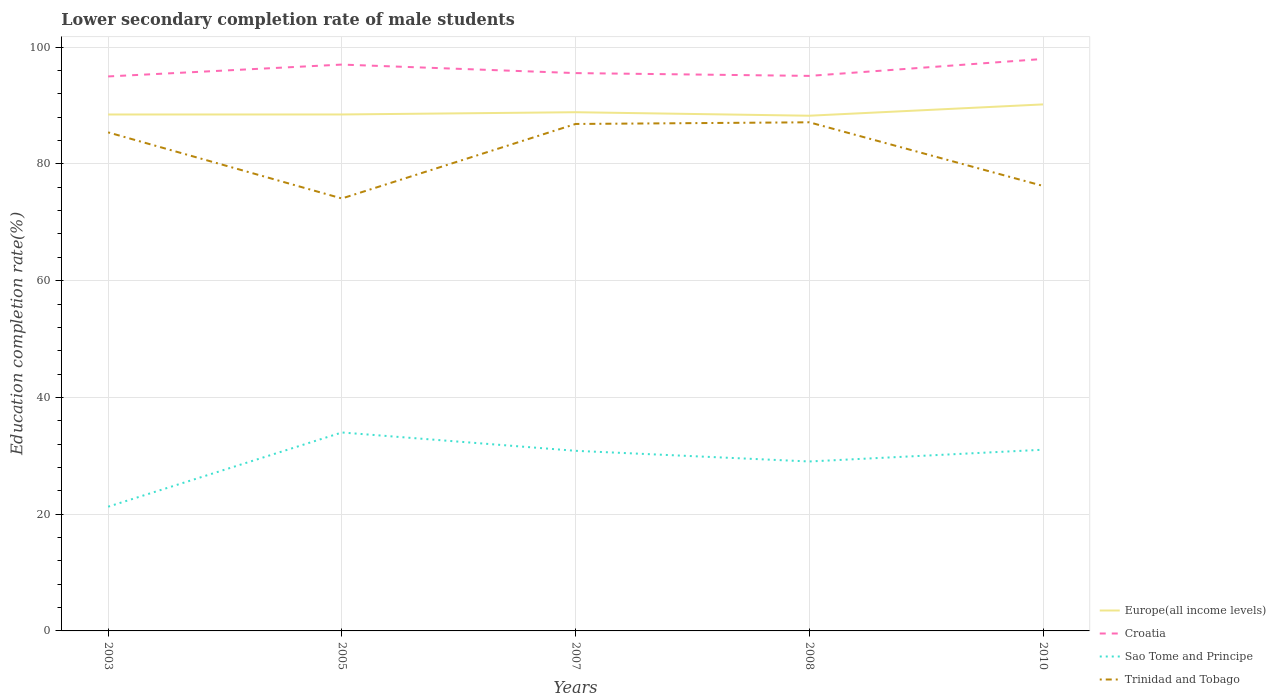Across all years, what is the maximum lower secondary completion rate of male students in Croatia?
Provide a short and direct response. 94.98. In which year was the lower secondary completion rate of male students in Croatia maximum?
Your answer should be very brief. 2003. What is the total lower secondary completion rate of male students in Croatia in the graph?
Give a very brief answer. 1.94. What is the difference between the highest and the second highest lower secondary completion rate of male students in Europe(all income levels)?
Offer a very short reply. 1.94. What is the difference between the highest and the lowest lower secondary completion rate of male students in Trinidad and Tobago?
Your response must be concise. 3. Is the lower secondary completion rate of male students in Sao Tome and Principe strictly greater than the lower secondary completion rate of male students in Croatia over the years?
Your answer should be very brief. Yes. How many years are there in the graph?
Make the answer very short. 5. What is the difference between two consecutive major ticks on the Y-axis?
Offer a terse response. 20. Are the values on the major ticks of Y-axis written in scientific E-notation?
Offer a very short reply. No. Where does the legend appear in the graph?
Provide a succinct answer. Bottom right. How many legend labels are there?
Your answer should be compact. 4. What is the title of the graph?
Offer a terse response. Lower secondary completion rate of male students. What is the label or title of the Y-axis?
Give a very brief answer. Education completion rate(%). What is the Education completion rate(%) in Europe(all income levels) in 2003?
Your answer should be very brief. 88.46. What is the Education completion rate(%) in Croatia in 2003?
Keep it short and to the point. 94.98. What is the Education completion rate(%) of Sao Tome and Principe in 2003?
Make the answer very short. 21.28. What is the Education completion rate(%) in Trinidad and Tobago in 2003?
Your answer should be compact. 85.4. What is the Education completion rate(%) in Europe(all income levels) in 2005?
Make the answer very short. 88.47. What is the Education completion rate(%) in Croatia in 2005?
Your answer should be very brief. 97.02. What is the Education completion rate(%) of Sao Tome and Principe in 2005?
Your response must be concise. 33.99. What is the Education completion rate(%) in Trinidad and Tobago in 2005?
Give a very brief answer. 74.08. What is the Education completion rate(%) in Europe(all income levels) in 2007?
Make the answer very short. 88.85. What is the Education completion rate(%) in Croatia in 2007?
Give a very brief answer. 95.56. What is the Education completion rate(%) of Sao Tome and Principe in 2007?
Your answer should be compact. 30.85. What is the Education completion rate(%) in Trinidad and Tobago in 2007?
Keep it short and to the point. 86.84. What is the Education completion rate(%) of Europe(all income levels) in 2008?
Make the answer very short. 88.25. What is the Education completion rate(%) in Croatia in 2008?
Your answer should be compact. 95.08. What is the Education completion rate(%) of Sao Tome and Principe in 2008?
Keep it short and to the point. 29.03. What is the Education completion rate(%) of Trinidad and Tobago in 2008?
Offer a terse response. 87.13. What is the Education completion rate(%) of Europe(all income levels) in 2010?
Your answer should be compact. 90.19. What is the Education completion rate(%) of Croatia in 2010?
Your response must be concise. 97.98. What is the Education completion rate(%) in Sao Tome and Principe in 2010?
Your answer should be compact. 31.04. What is the Education completion rate(%) in Trinidad and Tobago in 2010?
Make the answer very short. 76.23. Across all years, what is the maximum Education completion rate(%) in Europe(all income levels)?
Provide a short and direct response. 90.19. Across all years, what is the maximum Education completion rate(%) in Croatia?
Your answer should be compact. 97.98. Across all years, what is the maximum Education completion rate(%) of Sao Tome and Principe?
Keep it short and to the point. 33.99. Across all years, what is the maximum Education completion rate(%) in Trinidad and Tobago?
Your answer should be compact. 87.13. Across all years, what is the minimum Education completion rate(%) of Europe(all income levels)?
Provide a short and direct response. 88.25. Across all years, what is the minimum Education completion rate(%) in Croatia?
Your response must be concise. 94.98. Across all years, what is the minimum Education completion rate(%) in Sao Tome and Principe?
Offer a terse response. 21.28. Across all years, what is the minimum Education completion rate(%) of Trinidad and Tobago?
Provide a short and direct response. 74.08. What is the total Education completion rate(%) of Europe(all income levels) in the graph?
Make the answer very short. 444.23. What is the total Education completion rate(%) in Croatia in the graph?
Provide a short and direct response. 480.61. What is the total Education completion rate(%) in Sao Tome and Principe in the graph?
Ensure brevity in your answer.  146.19. What is the total Education completion rate(%) in Trinidad and Tobago in the graph?
Offer a terse response. 409.68. What is the difference between the Education completion rate(%) in Europe(all income levels) in 2003 and that in 2005?
Give a very brief answer. -0.01. What is the difference between the Education completion rate(%) in Croatia in 2003 and that in 2005?
Give a very brief answer. -2.03. What is the difference between the Education completion rate(%) in Sao Tome and Principe in 2003 and that in 2005?
Keep it short and to the point. -12.72. What is the difference between the Education completion rate(%) in Trinidad and Tobago in 2003 and that in 2005?
Offer a very short reply. 11.32. What is the difference between the Education completion rate(%) of Europe(all income levels) in 2003 and that in 2007?
Keep it short and to the point. -0.39. What is the difference between the Education completion rate(%) of Croatia in 2003 and that in 2007?
Offer a very short reply. -0.57. What is the difference between the Education completion rate(%) in Sao Tome and Principe in 2003 and that in 2007?
Make the answer very short. -9.57. What is the difference between the Education completion rate(%) of Trinidad and Tobago in 2003 and that in 2007?
Ensure brevity in your answer.  -1.44. What is the difference between the Education completion rate(%) of Europe(all income levels) in 2003 and that in 2008?
Make the answer very short. 0.21. What is the difference between the Education completion rate(%) of Croatia in 2003 and that in 2008?
Make the answer very short. -0.09. What is the difference between the Education completion rate(%) of Sao Tome and Principe in 2003 and that in 2008?
Provide a short and direct response. -7.75. What is the difference between the Education completion rate(%) of Trinidad and Tobago in 2003 and that in 2008?
Your response must be concise. -1.73. What is the difference between the Education completion rate(%) of Europe(all income levels) in 2003 and that in 2010?
Provide a short and direct response. -1.73. What is the difference between the Education completion rate(%) of Croatia in 2003 and that in 2010?
Your answer should be compact. -2.99. What is the difference between the Education completion rate(%) in Sao Tome and Principe in 2003 and that in 2010?
Keep it short and to the point. -9.76. What is the difference between the Education completion rate(%) in Trinidad and Tobago in 2003 and that in 2010?
Offer a very short reply. 9.17. What is the difference between the Education completion rate(%) of Europe(all income levels) in 2005 and that in 2007?
Provide a short and direct response. -0.39. What is the difference between the Education completion rate(%) in Croatia in 2005 and that in 2007?
Keep it short and to the point. 1.46. What is the difference between the Education completion rate(%) of Sao Tome and Principe in 2005 and that in 2007?
Offer a terse response. 3.14. What is the difference between the Education completion rate(%) of Trinidad and Tobago in 2005 and that in 2007?
Provide a succinct answer. -12.76. What is the difference between the Education completion rate(%) of Europe(all income levels) in 2005 and that in 2008?
Keep it short and to the point. 0.21. What is the difference between the Education completion rate(%) in Croatia in 2005 and that in 2008?
Your answer should be compact. 1.94. What is the difference between the Education completion rate(%) of Sao Tome and Principe in 2005 and that in 2008?
Keep it short and to the point. 4.97. What is the difference between the Education completion rate(%) of Trinidad and Tobago in 2005 and that in 2008?
Offer a terse response. -13.05. What is the difference between the Education completion rate(%) in Europe(all income levels) in 2005 and that in 2010?
Make the answer very short. -1.72. What is the difference between the Education completion rate(%) in Croatia in 2005 and that in 2010?
Keep it short and to the point. -0.96. What is the difference between the Education completion rate(%) of Sao Tome and Principe in 2005 and that in 2010?
Ensure brevity in your answer.  2.96. What is the difference between the Education completion rate(%) of Trinidad and Tobago in 2005 and that in 2010?
Provide a short and direct response. -2.15. What is the difference between the Education completion rate(%) of Europe(all income levels) in 2007 and that in 2008?
Provide a short and direct response. 0.6. What is the difference between the Education completion rate(%) of Croatia in 2007 and that in 2008?
Offer a very short reply. 0.48. What is the difference between the Education completion rate(%) in Sao Tome and Principe in 2007 and that in 2008?
Ensure brevity in your answer.  1.83. What is the difference between the Education completion rate(%) in Trinidad and Tobago in 2007 and that in 2008?
Offer a terse response. -0.29. What is the difference between the Education completion rate(%) in Europe(all income levels) in 2007 and that in 2010?
Your answer should be compact. -1.34. What is the difference between the Education completion rate(%) of Croatia in 2007 and that in 2010?
Offer a terse response. -2.42. What is the difference between the Education completion rate(%) in Sao Tome and Principe in 2007 and that in 2010?
Offer a terse response. -0.19. What is the difference between the Education completion rate(%) of Trinidad and Tobago in 2007 and that in 2010?
Ensure brevity in your answer.  10.61. What is the difference between the Education completion rate(%) in Europe(all income levels) in 2008 and that in 2010?
Your answer should be compact. -1.94. What is the difference between the Education completion rate(%) in Croatia in 2008 and that in 2010?
Offer a terse response. -2.9. What is the difference between the Education completion rate(%) in Sao Tome and Principe in 2008 and that in 2010?
Provide a short and direct response. -2.01. What is the difference between the Education completion rate(%) of Trinidad and Tobago in 2008 and that in 2010?
Make the answer very short. 10.9. What is the difference between the Education completion rate(%) in Europe(all income levels) in 2003 and the Education completion rate(%) in Croatia in 2005?
Offer a terse response. -8.55. What is the difference between the Education completion rate(%) of Europe(all income levels) in 2003 and the Education completion rate(%) of Sao Tome and Principe in 2005?
Ensure brevity in your answer.  54.47. What is the difference between the Education completion rate(%) of Europe(all income levels) in 2003 and the Education completion rate(%) of Trinidad and Tobago in 2005?
Give a very brief answer. 14.39. What is the difference between the Education completion rate(%) of Croatia in 2003 and the Education completion rate(%) of Sao Tome and Principe in 2005?
Ensure brevity in your answer.  60.99. What is the difference between the Education completion rate(%) in Croatia in 2003 and the Education completion rate(%) in Trinidad and Tobago in 2005?
Your response must be concise. 20.91. What is the difference between the Education completion rate(%) of Sao Tome and Principe in 2003 and the Education completion rate(%) of Trinidad and Tobago in 2005?
Make the answer very short. -52.8. What is the difference between the Education completion rate(%) of Europe(all income levels) in 2003 and the Education completion rate(%) of Croatia in 2007?
Make the answer very short. -7.09. What is the difference between the Education completion rate(%) in Europe(all income levels) in 2003 and the Education completion rate(%) in Sao Tome and Principe in 2007?
Give a very brief answer. 57.61. What is the difference between the Education completion rate(%) in Europe(all income levels) in 2003 and the Education completion rate(%) in Trinidad and Tobago in 2007?
Offer a very short reply. 1.62. What is the difference between the Education completion rate(%) in Croatia in 2003 and the Education completion rate(%) in Sao Tome and Principe in 2007?
Make the answer very short. 64.13. What is the difference between the Education completion rate(%) of Croatia in 2003 and the Education completion rate(%) of Trinidad and Tobago in 2007?
Offer a very short reply. 8.14. What is the difference between the Education completion rate(%) of Sao Tome and Principe in 2003 and the Education completion rate(%) of Trinidad and Tobago in 2007?
Keep it short and to the point. -65.56. What is the difference between the Education completion rate(%) of Europe(all income levels) in 2003 and the Education completion rate(%) of Croatia in 2008?
Give a very brief answer. -6.61. What is the difference between the Education completion rate(%) in Europe(all income levels) in 2003 and the Education completion rate(%) in Sao Tome and Principe in 2008?
Give a very brief answer. 59.44. What is the difference between the Education completion rate(%) in Europe(all income levels) in 2003 and the Education completion rate(%) in Trinidad and Tobago in 2008?
Offer a very short reply. 1.34. What is the difference between the Education completion rate(%) of Croatia in 2003 and the Education completion rate(%) of Sao Tome and Principe in 2008?
Offer a terse response. 65.96. What is the difference between the Education completion rate(%) of Croatia in 2003 and the Education completion rate(%) of Trinidad and Tobago in 2008?
Keep it short and to the point. 7.86. What is the difference between the Education completion rate(%) of Sao Tome and Principe in 2003 and the Education completion rate(%) of Trinidad and Tobago in 2008?
Offer a terse response. -65.85. What is the difference between the Education completion rate(%) of Europe(all income levels) in 2003 and the Education completion rate(%) of Croatia in 2010?
Keep it short and to the point. -9.51. What is the difference between the Education completion rate(%) in Europe(all income levels) in 2003 and the Education completion rate(%) in Sao Tome and Principe in 2010?
Your answer should be compact. 57.42. What is the difference between the Education completion rate(%) of Europe(all income levels) in 2003 and the Education completion rate(%) of Trinidad and Tobago in 2010?
Provide a succinct answer. 12.23. What is the difference between the Education completion rate(%) of Croatia in 2003 and the Education completion rate(%) of Sao Tome and Principe in 2010?
Offer a terse response. 63.94. What is the difference between the Education completion rate(%) in Croatia in 2003 and the Education completion rate(%) in Trinidad and Tobago in 2010?
Provide a short and direct response. 18.75. What is the difference between the Education completion rate(%) in Sao Tome and Principe in 2003 and the Education completion rate(%) in Trinidad and Tobago in 2010?
Make the answer very short. -54.95. What is the difference between the Education completion rate(%) in Europe(all income levels) in 2005 and the Education completion rate(%) in Croatia in 2007?
Your response must be concise. -7.09. What is the difference between the Education completion rate(%) in Europe(all income levels) in 2005 and the Education completion rate(%) in Sao Tome and Principe in 2007?
Your response must be concise. 57.62. What is the difference between the Education completion rate(%) of Europe(all income levels) in 2005 and the Education completion rate(%) of Trinidad and Tobago in 2007?
Ensure brevity in your answer.  1.63. What is the difference between the Education completion rate(%) of Croatia in 2005 and the Education completion rate(%) of Sao Tome and Principe in 2007?
Offer a terse response. 66.16. What is the difference between the Education completion rate(%) of Croatia in 2005 and the Education completion rate(%) of Trinidad and Tobago in 2007?
Your response must be concise. 10.17. What is the difference between the Education completion rate(%) in Sao Tome and Principe in 2005 and the Education completion rate(%) in Trinidad and Tobago in 2007?
Ensure brevity in your answer.  -52.85. What is the difference between the Education completion rate(%) of Europe(all income levels) in 2005 and the Education completion rate(%) of Croatia in 2008?
Offer a terse response. -6.61. What is the difference between the Education completion rate(%) of Europe(all income levels) in 2005 and the Education completion rate(%) of Sao Tome and Principe in 2008?
Ensure brevity in your answer.  59.44. What is the difference between the Education completion rate(%) in Europe(all income levels) in 2005 and the Education completion rate(%) in Trinidad and Tobago in 2008?
Give a very brief answer. 1.34. What is the difference between the Education completion rate(%) of Croatia in 2005 and the Education completion rate(%) of Sao Tome and Principe in 2008?
Provide a succinct answer. 67.99. What is the difference between the Education completion rate(%) of Croatia in 2005 and the Education completion rate(%) of Trinidad and Tobago in 2008?
Keep it short and to the point. 9.89. What is the difference between the Education completion rate(%) of Sao Tome and Principe in 2005 and the Education completion rate(%) of Trinidad and Tobago in 2008?
Your answer should be compact. -53.13. What is the difference between the Education completion rate(%) of Europe(all income levels) in 2005 and the Education completion rate(%) of Croatia in 2010?
Offer a terse response. -9.51. What is the difference between the Education completion rate(%) in Europe(all income levels) in 2005 and the Education completion rate(%) in Sao Tome and Principe in 2010?
Give a very brief answer. 57.43. What is the difference between the Education completion rate(%) of Europe(all income levels) in 2005 and the Education completion rate(%) of Trinidad and Tobago in 2010?
Make the answer very short. 12.24. What is the difference between the Education completion rate(%) of Croatia in 2005 and the Education completion rate(%) of Sao Tome and Principe in 2010?
Give a very brief answer. 65.98. What is the difference between the Education completion rate(%) of Croatia in 2005 and the Education completion rate(%) of Trinidad and Tobago in 2010?
Make the answer very short. 20.79. What is the difference between the Education completion rate(%) of Sao Tome and Principe in 2005 and the Education completion rate(%) of Trinidad and Tobago in 2010?
Provide a succinct answer. -42.23. What is the difference between the Education completion rate(%) in Europe(all income levels) in 2007 and the Education completion rate(%) in Croatia in 2008?
Offer a terse response. -6.22. What is the difference between the Education completion rate(%) in Europe(all income levels) in 2007 and the Education completion rate(%) in Sao Tome and Principe in 2008?
Your response must be concise. 59.83. What is the difference between the Education completion rate(%) in Europe(all income levels) in 2007 and the Education completion rate(%) in Trinidad and Tobago in 2008?
Make the answer very short. 1.73. What is the difference between the Education completion rate(%) in Croatia in 2007 and the Education completion rate(%) in Sao Tome and Principe in 2008?
Your answer should be compact. 66.53. What is the difference between the Education completion rate(%) in Croatia in 2007 and the Education completion rate(%) in Trinidad and Tobago in 2008?
Ensure brevity in your answer.  8.43. What is the difference between the Education completion rate(%) of Sao Tome and Principe in 2007 and the Education completion rate(%) of Trinidad and Tobago in 2008?
Offer a very short reply. -56.27. What is the difference between the Education completion rate(%) in Europe(all income levels) in 2007 and the Education completion rate(%) in Croatia in 2010?
Give a very brief answer. -9.12. What is the difference between the Education completion rate(%) of Europe(all income levels) in 2007 and the Education completion rate(%) of Sao Tome and Principe in 2010?
Offer a very short reply. 57.81. What is the difference between the Education completion rate(%) of Europe(all income levels) in 2007 and the Education completion rate(%) of Trinidad and Tobago in 2010?
Keep it short and to the point. 12.62. What is the difference between the Education completion rate(%) of Croatia in 2007 and the Education completion rate(%) of Sao Tome and Principe in 2010?
Your answer should be very brief. 64.52. What is the difference between the Education completion rate(%) in Croatia in 2007 and the Education completion rate(%) in Trinidad and Tobago in 2010?
Ensure brevity in your answer.  19.33. What is the difference between the Education completion rate(%) of Sao Tome and Principe in 2007 and the Education completion rate(%) of Trinidad and Tobago in 2010?
Keep it short and to the point. -45.38. What is the difference between the Education completion rate(%) of Europe(all income levels) in 2008 and the Education completion rate(%) of Croatia in 2010?
Your answer should be compact. -9.72. What is the difference between the Education completion rate(%) of Europe(all income levels) in 2008 and the Education completion rate(%) of Sao Tome and Principe in 2010?
Your response must be concise. 57.21. What is the difference between the Education completion rate(%) of Europe(all income levels) in 2008 and the Education completion rate(%) of Trinidad and Tobago in 2010?
Offer a terse response. 12.02. What is the difference between the Education completion rate(%) of Croatia in 2008 and the Education completion rate(%) of Sao Tome and Principe in 2010?
Offer a very short reply. 64.04. What is the difference between the Education completion rate(%) in Croatia in 2008 and the Education completion rate(%) in Trinidad and Tobago in 2010?
Give a very brief answer. 18.85. What is the difference between the Education completion rate(%) of Sao Tome and Principe in 2008 and the Education completion rate(%) of Trinidad and Tobago in 2010?
Offer a very short reply. -47.2. What is the average Education completion rate(%) of Europe(all income levels) per year?
Keep it short and to the point. 88.85. What is the average Education completion rate(%) of Croatia per year?
Make the answer very short. 96.12. What is the average Education completion rate(%) in Sao Tome and Principe per year?
Offer a terse response. 29.24. What is the average Education completion rate(%) in Trinidad and Tobago per year?
Ensure brevity in your answer.  81.94. In the year 2003, what is the difference between the Education completion rate(%) in Europe(all income levels) and Education completion rate(%) in Croatia?
Give a very brief answer. -6.52. In the year 2003, what is the difference between the Education completion rate(%) in Europe(all income levels) and Education completion rate(%) in Sao Tome and Principe?
Give a very brief answer. 67.18. In the year 2003, what is the difference between the Education completion rate(%) of Europe(all income levels) and Education completion rate(%) of Trinidad and Tobago?
Keep it short and to the point. 3.06. In the year 2003, what is the difference between the Education completion rate(%) in Croatia and Education completion rate(%) in Sao Tome and Principe?
Provide a succinct answer. 73.7. In the year 2003, what is the difference between the Education completion rate(%) of Croatia and Education completion rate(%) of Trinidad and Tobago?
Offer a terse response. 9.58. In the year 2003, what is the difference between the Education completion rate(%) in Sao Tome and Principe and Education completion rate(%) in Trinidad and Tobago?
Provide a succinct answer. -64.12. In the year 2005, what is the difference between the Education completion rate(%) in Europe(all income levels) and Education completion rate(%) in Croatia?
Your response must be concise. -8.55. In the year 2005, what is the difference between the Education completion rate(%) of Europe(all income levels) and Education completion rate(%) of Sao Tome and Principe?
Ensure brevity in your answer.  54.47. In the year 2005, what is the difference between the Education completion rate(%) of Europe(all income levels) and Education completion rate(%) of Trinidad and Tobago?
Make the answer very short. 14.39. In the year 2005, what is the difference between the Education completion rate(%) of Croatia and Education completion rate(%) of Sao Tome and Principe?
Give a very brief answer. 63.02. In the year 2005, what is the difference between the Education completion rate(%) in Croatia and Education completion rate(%) in Trinidad and Tobago?
Your answer should be compact. 22.94. In the year 2005, what is the difference between the Education completion rate(%) of Sao Tome and Principe and Education completion rate(%) of Trinidad and Tobago?
Give a very brief answer. -40.08. In the year 2007, what is the difference between the Education completion rate(%) of Europe(all income levels) and Education completion rate(%) of Croatia?
Offer a very short reply. -6.7. In the year 2007, what is the difference between the Education completion rate(%) of Europe(all income levels) and Education completion rate(%) of Sao Tome and Principe?
Your response must be concise. 58. In the year 2007, what is the difference between the Education completion rate(%) in Europe(all income levels) and Education completion rate(%) in Trinidad and Tobago?
Offer a very short reply. 2.01. In the year 2007, what is the difference between the Education completion rate(%) of Croatia and Education completion rate(%) of Sao Tome and Principe?
Offer a terse response. 64.7. In the year 2007, what is the difference between the Education completion rate(%) in Croatia and Education completion rate(%) in Trinidad and Tobago?
Give a very brief answer. 8.72. In the year 2007, what is the difference between the Education completion rate(%) of Sao Tome and Principe and Education completion rate(%) of Trinidad and Tobago?
Provide a short and direct response. -55.99. In the year 2008, what is the difference between the Education completion rate(%) in Europe(all income levels) and Education completion rate(%) in Croatia?
Provide a succinct answer. -6.82. In the year 2008, what is the difference between the Education completion rate(%) of Europe(all income levels) and Education completion rate(%) of Sao Tome and Principe?
Offer a terse response. 59.23. In the year 2008, what is the difference between the Education completion rate(%) in Europe(all income levels) and Education completion rate(%) in Trinidad and Tobago?
Ensure brevity in your answer.  1.13. In the year 2008, what is the difference between the Education completion rate(%) in Croatia and Education completion rate(%) in Sao Tome and Principe?
Your answer should be compact. 66.05. In the year 2008, what is the difference between the Education completion rate(%) of Croatia and Education completion rate(%) of Trinidad and Tobago?
Ensure brevity in your answer.  7.95. In the year 2008, what is the difference between the Education completion rate(%) in Sao Tome and Principe and Education completion rate(%) in Trinidad and Tobago?
Make the answer very short. -58.1. In the year 2010, what is the difference between the Education completion rate(%) of Europe(all income levels) and Education completion rate(%) of Croatia?
Offer a terse response. -7.79. In the year 2010, what is the difference between the Education completion rate(%) of Europe(all income levels) and Education completion rate(%) of Sao Tome and Principe?
Offer a terse response. 59.15. In the year 2010, what is the difference between the Education completion rate(%) of Europe(all income levels) and Education completion rate(%) of Trinidad and Tobago?
Your response must be concise. 13.96. In the year 2010, what is the difference between the Education completion rate(%) in Croatia and Education completion rate(%) in Sao Tome and Principe?
Offer a very short reply. 66.94. In the year 2010, what is the difference between the Education completion rate(%) in Croatia and Education completion rate(%) in Trinidad and Tobago?
Make the answer very short. 21.75. In the year 2010, what is the difference between the Education completion rate(%) of Sao Tome and Principe and Education completion rate(%) of Trinidad and Tobago?
Provide a succinct answer. -45.19. What is the ratio of the Education completion rate(%) in Europe(all income levels) in 2003 to that in 2005?
Make the answer very short. 1. What is the ratio of the Education completion rate(%) of Croatia in 2003 to that in 2005?
Provide a succinct answer. 0.98. What is the ratio of the Education completion rate(%) of Sao Tome and Principe in 2003 to that in 2005?
Keep it short and to the point. 0.63. What is the ratio of the Education completion rate(%) of Trinidad and Tobago in 2003 to that in 2005?
Your answer should be compact. 1.15. What is the ratio of the Education completion rate(%) of Croatia in 2003 to that in 2007?
Your answer should be very brief. 0.99. What is the ratio of the Education completion rate(%) in Sao Tome and Principe in 2003 to that in 2007?
Offer a very short reply. 0.69. What is the ratio of the Education completion rate(%) in Trinidad and Tobago in 2003 to that in 2007?
Keep it short and to the point. 0.98. What is the ratio of the Education completion rate(%) of Croatia in 2003 to that in 2008?
Your answer should be compact. 1. What is the ratio of the Education completion rate(%) in Sao Tome and Principe in 2003 to that in 2008?
Keep it short and to the point. 0.73. What is the ratio of the Education completion rate(%) of Trinidad and Tobago in 2003 to that in 2008?
Your response must be concise. 0.98. What is the ratio of the Education completion rate(%) of Europe(all income levels) in 2003 to that in 2010?
Ensure brevity in your answer.  0.98. What is the ratio of the Education completion rate(%) in Croatia in 2003 to that in 2010?
Offer a very short reply. 0.97. What is the ratio of the Education completion rate(%) of Sao Tome and Principe in 2003 to that in 2010?
Provide a succinct answer. 0.69. What is the ratio of the Education completion rate(%) of Trinidad and Tobago in 2003 to that in 2010?
Your answer should be very brief. 1.12. What is the ratio of the Education completion rate(%) of Europe(all income levels) in 2005 to that in 2007?
Your answer should be very brief. 1. What is the ratio of the Education completion rate(%) of Croatia in 2005 to that in 2007?
Your answer should be very brief. 1.02. What is the ratio of the Education completion rate(%) in Sao Tome and Principe in 2005 to that in 2007?
Give a very brief answer. 1.1. What is the ratio of the Education completion rate(%) of Trinidad and Tobago in 2005 to that in 2007?
Keep it short and to the point. 0.85. What is the ratio of the Education completion rate(%) of Europe(all income levels) in 2005 to that in 2008?
Ensure brevity in your answer.  1. What is the ratio of the Education completion rate(%) in Croatia in 2005 to that in 2008?
Offer a very short reply. 1.02. What is the ratio of the Education completion rate(%) of Sao Tome and Principe in 2005 to that in 2008?
Make the answer very short. 1.17. What is the ratio of the Education completion rate(%) of Trinidad and Tobago in 2005 to that in 2008?
Ensure brevity in your answer.  0.85. What is the ratio of the Education completion rate(%) in Europe(all income levels) in 2005 to that in 2010?
Give a very brief answer. 0.98. What is the ratio of the Education completion rate(%) in Croatia in 2005 to that in 2010?
Your response must be concise. 0.99. What is the ratio of the Education completion rate(%) of Sao Tome and Principe in 2005 to that in 2010?
Provide a succinct answer. 1.1. What is the ratio of the Education completion rate(%) in Trinidad and Tobago in 2005 to that in 2010?
Your answer should be very brief. 0.97. What is the ratio of the Education completion rate(%) of Europe(all income levels) in 2007 to that in 2008?
Keep it short and to the point. 1.01. What is the ratio of the Education completion rate(%) in Croatia in 2007 to that in 2008?
Your answer should be very brief. 1.01. What is the ratio of the Education completion rate(%) in Sao Tome and Principe in 2007 to that in 2008?
Your answer should be compact. 1.06. What is the ratio of the Education completion rate(%) in Europe(all income levels) in 2007 to that in 2010?
Make the answer very short. 0.99. What is the ratio of the Education completion rate(%) of Croatia in 2007 to that in 2010?
Keep it short and to the point. 0.98. What is the ratio of the Education completion rate(%) of Trinidad and Tobago in 2007 to that in 2010?
Offer a terse response. 1.14. What is the ratio of the Education completion rate(%) of Europe(all income levels) in 2008 to that in 2010?
Make the answer very short. 0.98. What is the ratio of the Education completion rate(%) of Croatia in 2008 to that in 2010?
Your answer should be compact. 0.97. What is the ratio of the Education completion rate(%) of Sao Tome and Principe in 2008 to that in 2010?
Your response must be concise. 0.94. What is the ratio of the Education completion rate(%) of Trinidad and Tobago in 2008 to that in 2010?
Give a very brief answer. 1.14. What is the difference between the highest and the second highest Education completion rate(%) in Europe(all income levels)?
Offer a very short reply. 1.34. What is the difference between the highest and the second highest Education completion rate(%) in Croatia?
Provide a short and direct response. 0.96. What is the difference between the highest and the second highest Education completion rate(%) in Sao Tome and Principe?
Your answer should be compact. 2.96. What is the difference between the highest and the second highest Education completion rate(%) in Trinidad and Tobago?
Your answer should be compact. 0.29. What is the difference between the highest and the lowest Education completion rate(%) in Europe(all income levels)?
Provide a succinct answer. 1.94. What is the difference between the highest and the lowest Education completion rate(%) in Croatia?
Offer a very short reply. 2.99. What is the difference between the highest and the lowest Education completion rate(%) of Sao Tome and Principe?
Your answer should be compact. 12.72. What is the difference between the highest and the lowest Education completion rate(%) in Trinidad and Tobago?
Give a very brief answer. 13.05. 